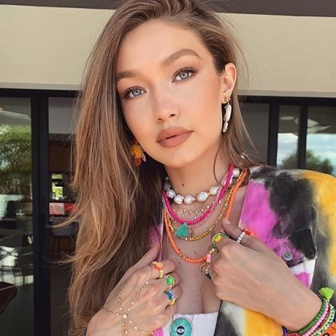What's happening in the scene? In the image, a young woman with striking blue eyes and long blonde hair stands as the central figure. She is adorned in a vibrant tie-dye shirt, showcasing a burst of colors that align with her bohemian aesthetic. Multiple necklaces and earrings adorn her, adding a touch of eclectic charm. Her hands are gently raised to her chest, which could signify surprise, excitement, or a contemplative gesture. She is looking directly at the camera, creating a strong connection with the viewer. The background reveals an urban setting with a visible building facade punctuated by a window, alongside the green leaves of a nearby tree, suggesting an outdoor city environment. The contrast between her colorful attire and the relatively muted background emphasizes her presence, infusing the image with a youthful and energetic vibe. This image seems to capture a moment of contemporary urban life. 